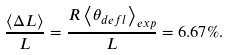<formula> <loc_0><loc_0><loc_500><loc_500>\frac { \left \langle \Delta L \right \rangle } { L } = \frac { R \left \langle \theta _ { d e f l } \right \rangle _ { e x p } } { L } = 6 . 6 7 \% .</formula> 